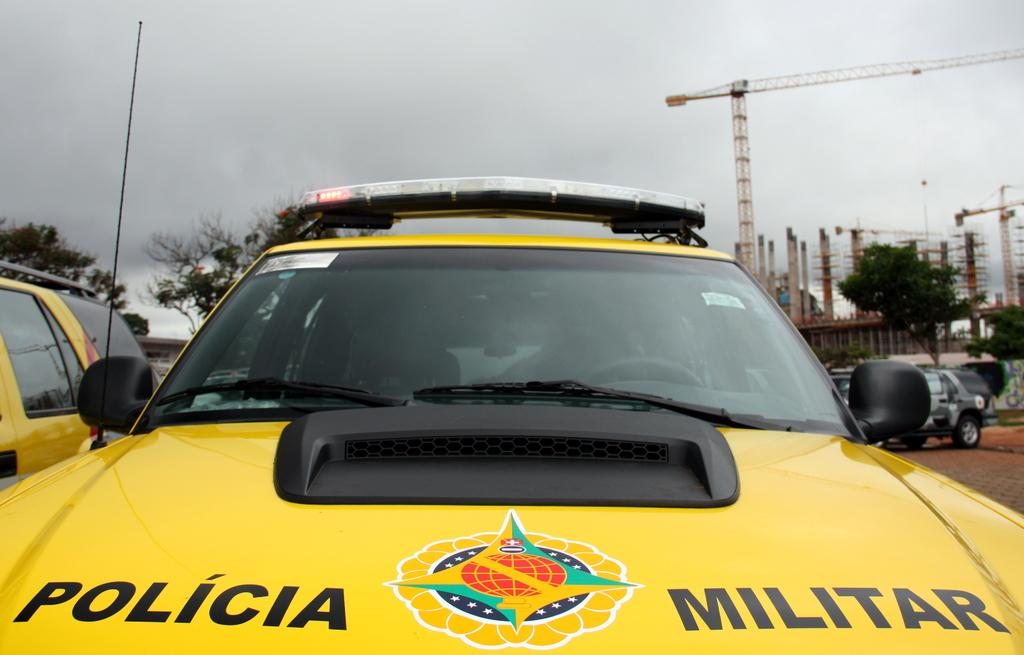What color are the vehicles in the image? The vehicles in the image are yellow. What can be seen in the background of the image? The sky is visible in the image. What structure is visible in the image? There is a tower visible in the image. What are the poles used for in the image? The purpose of the poles in the image is not specified, but they could be used for various purposes such as supporting wires or signs. Where is the vehicle located in the image? There is a vehicle on the right side of the image. What type of lace is draped over the tower in the image? There is no lace present in the image; it features yellow vehicles, a tower, poles, and a vehicle on the right side. What is the selection of vehicles available in the image? The image only shows one type of vehicle, which is yellow. 